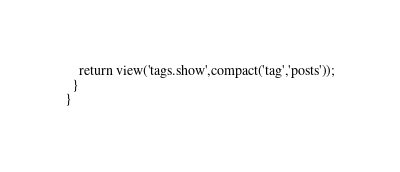Convert code to text. <code><loc_0><loc_0><loc_500><loc_500><_PHP_>    return view('tags.show',compact('tag','posts'));
  }
}
</code> 